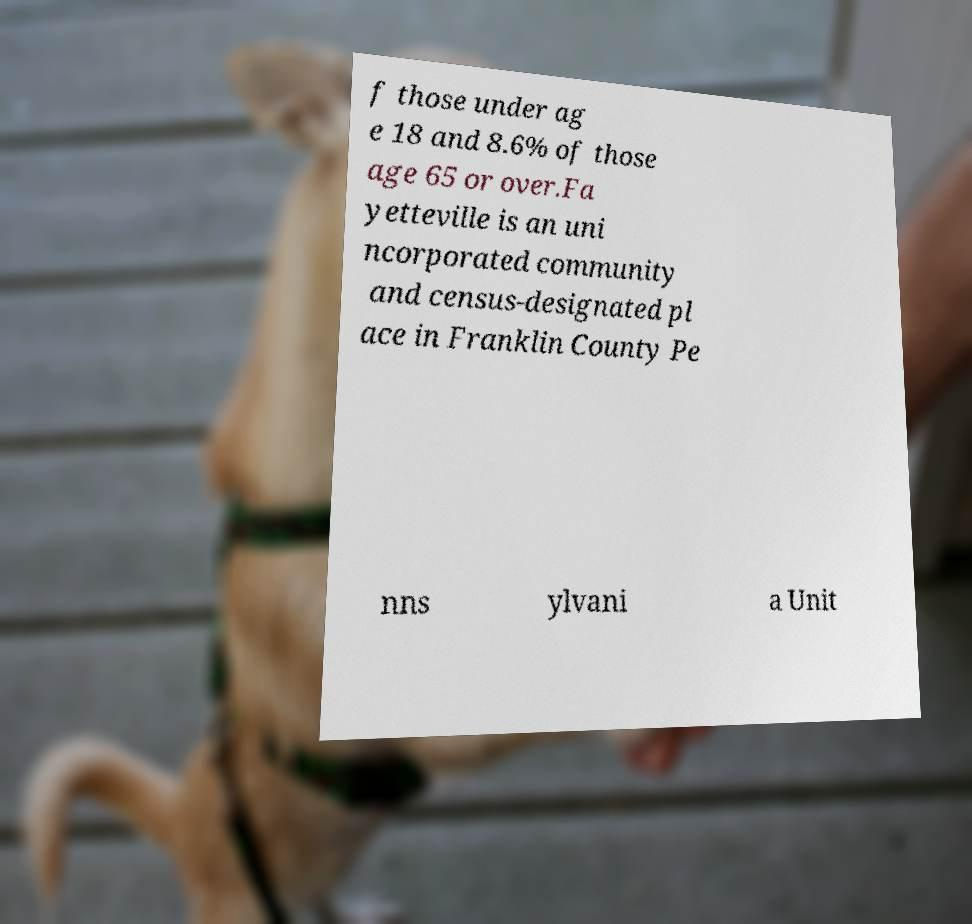Can you read and provide the text displayed in the image?This photo seems to have some interesting text. Can you extract and type it out for me? f those under ag e 18 and 8.6% of those age 65 or over.Fa yetteville is an uni ncorporated community and census-designated pl ace in Franklin County Pe nns ylvani a Unit 